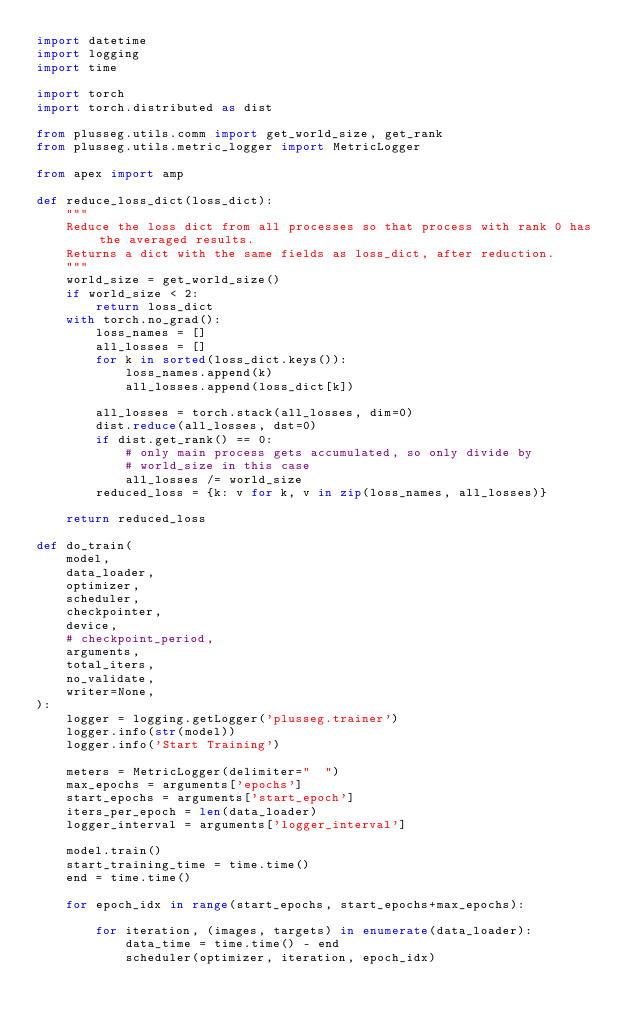Convert code to text. <code><loc_0><loc_0><loc_500><loc_500><_Python_>import datetime
import logging
import time

import torch
import torch.distributed as dist

from plusseg.utils.comm import get_world_size, get_rank
from plusseg.utils.metric_logger import MetricLogger

from apex import amp

def reduce_loss_dict(loss_dict):
    """
    Reduce the loss dict from all processes so that process with rank 0 has the averaged results.
    Returns a dict with the same fields as loss_dict, after reduction.
    """
    world_size = get_world_size()
    if world_size < 2:
        return loss_dict
    with torch.no_grad():
        loss_names = []
        all_losses = []
        for k in sorted(loss_dict.keys()):
            loss_names.append(k)
            all_losses.append(loss_dict[k])
        
        all_losses = torch.stack(all_losses, dim=0)
        dist.reduce(all_losses, dst=0)
        if dist.get_rank() == 0:
            # only main process gets accumulated, so only divide by
            # world_size in this case
            all_losses /= world_size
        reduced_loss = {k: v for k, v in zip(loss_names, all_losses)}
    
    return reduced_loss

def do_train(
    model,
    data_loader,
    optimizer,
    scheduler,
    checkpointer,
    device,
    # checkpoint_period,
    arguments,
    total_iters,
    no_validate,
    writer=None,
):
    logger = logging.getLogger('plusseg.trainer')
    logger.info(str(model))
    logger.info('Start Training')

    meters = MetricLogger(delimiter="  ")
    max_epochs = arguments['epochs']
    start_epochs = arguments['start_epoch']
    iters_per_epoch = len(data_loader)
    logger_interval = arguments['logger_interval']
    
    model.train()
    start_training_time = time.time()
    end = time.time()

    for epoch_idx in range(start_epochs, start_epochs+max_epochs):
        
        for iteration, (images, targets) in enumerate(data_loader):
            data_time = time.time() - end 
            scheduler(optimizer, iteration, epoch_idx)
</code> 